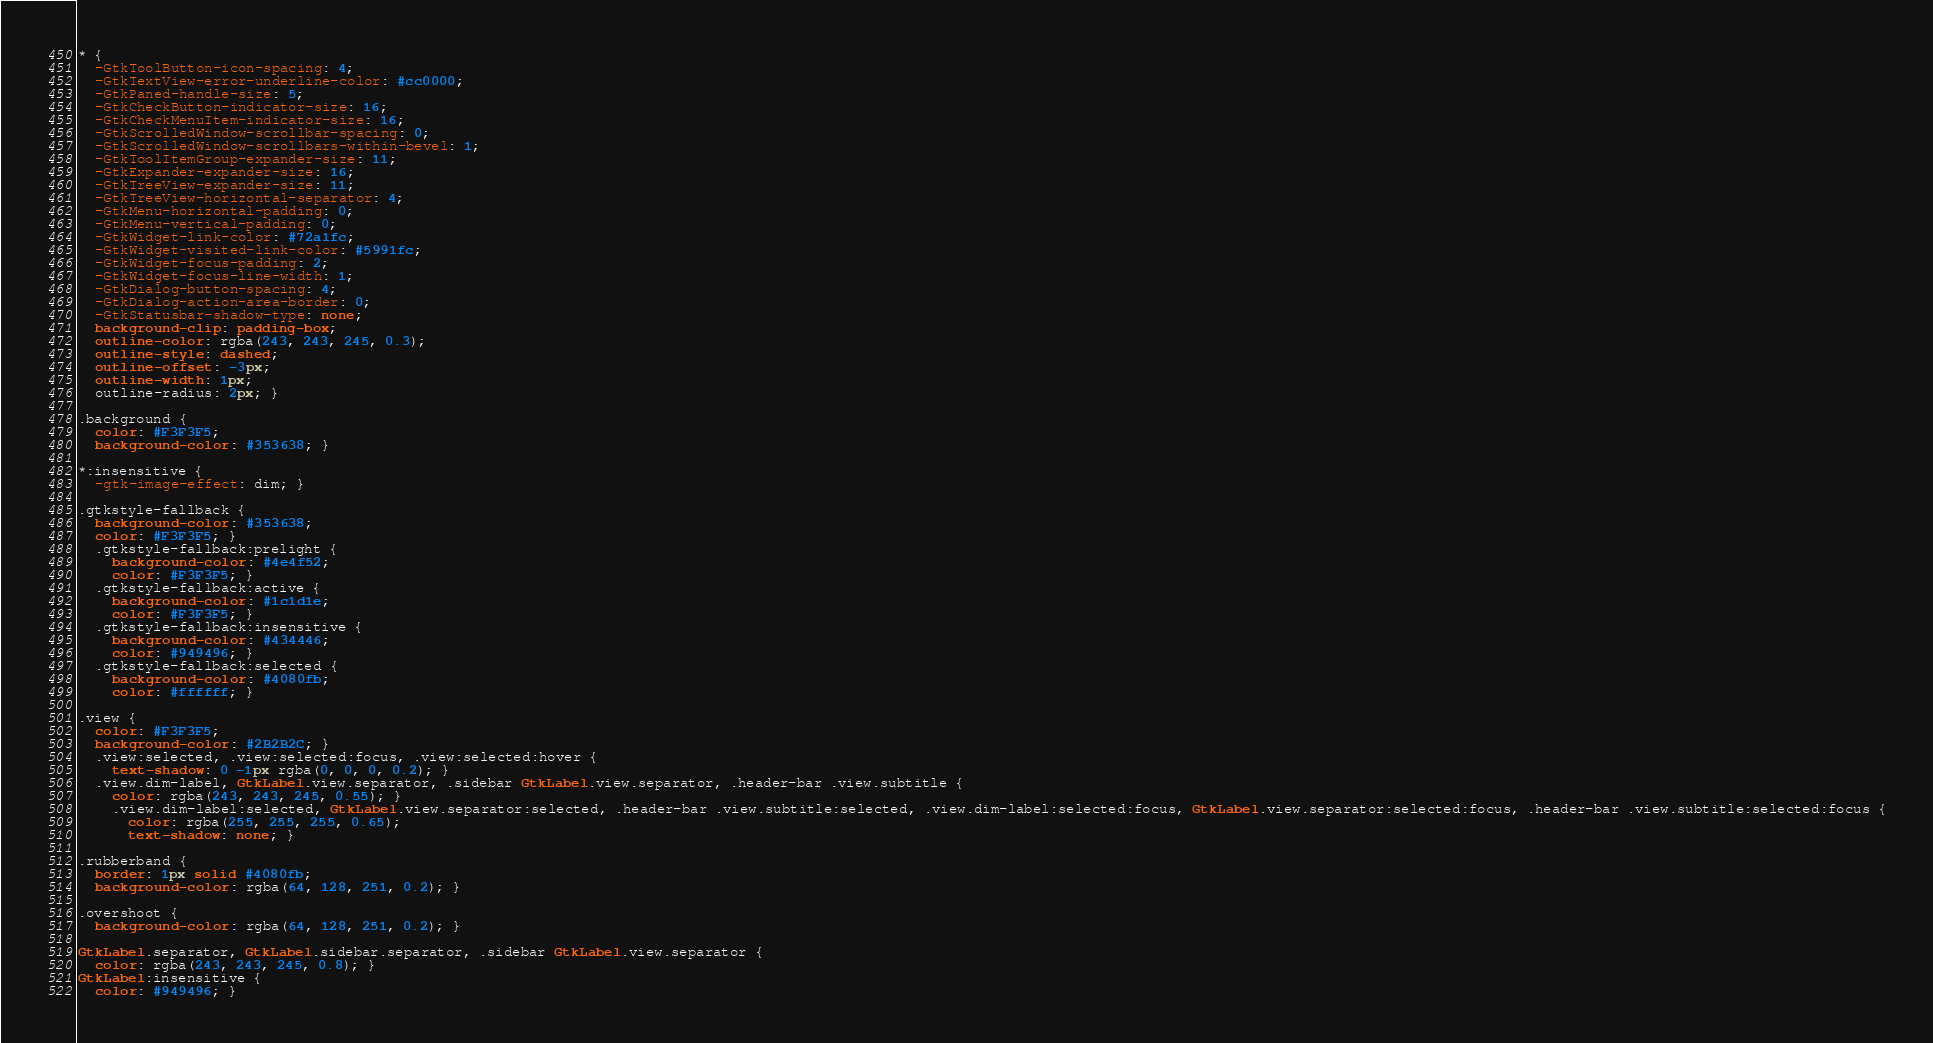<code> <loc_0><loc_0><loc_500><loc_500><_CSS_>* {
  -GtkToolButton-icon-spacing: 4;
  -GtkTextView-error-underline-color: #cc0000;
  -GtkPaned-handle-size: 5;
  -GtkCheckButton-indicator-size: 16;
  -GtkCheckMenuItem-indicator-size: 16;
  -GtkScrolledWindow-scrollbar-spacing: 0;
  -GtkScrolledWindow-scrollbars-within-bevel: 1;
  -GtkToolItemGroup-expander-size: 11;
  -GtkExpander-expander-size: 16;
  -GtkTreeView-expander-size: 11;
  -GtkTreeView-horizontal-separator: 4;
  -GtkMenu-horizontal-padding: 0;
  -GtkMenu-vertical-padding: 0;
  -GtkWidget-link-color: #72a1fc;
  -GtkWidget-visited-link-color: #5991fc;
  -GtkWidget-focus-padding: 2;
  -GtkWidget-focus-line-width: 1;
  -GtkDialog-button-spacing: 4;
  -GtkDialog-action-area-border: 0;
  -GtkStatusbar-shadow-type: none;
  background-clip: padding-box;
  outline-color: rgba(243, 243, 245, 0.3);
  outline-style: dashed;
  outline-offset: -3px;
  outline-width: 1px;
  outline-radius: 2px; }

.background {
  color: #F3F3F5;
  background-color: #353638; }

*:insensitive {
  -gtk-image-effect: dim; }

.gtkstyle-fallback {
  background-color: #353638;
  color: #F3F3F5; }
  .gtkstyle-fallback:prelight {
    background-color: #4e4f52;
    color: #F3F3F5; }
  .gtkstyle-fallback:active {
    background-color: #1c1d1e;
    color: #F3F3F5; }
  .gtkstyle-fallback:insensitive {
    background-color: #434446;
    color: #949496; }
  .gtkstyle-fallback:selected {
    background-color: #4080fb;
    color: #ffffff; }

.view {
  color: #F3F3F5;
  background-color: #2B2B2C; }
  .view:selected, .view:selected:focus, .view:selected:hover {
    text-shadow: 0 -1px rgba(0, 0, 0, 0.2); }
  .view.dim-label, GtkLabel.view.separator, .sidebar GtkLabel.view.separator, .header-bar .view.subtitle {
    color: rgba(243, 243, 245, 0.55); }
    .view.dim-label:selected, GtkLabel.view.separator:selected, .header-bar .view.subtitle:selected, .view.dim-label:selected:focus, GtkLabel.view.separator:selected:focus, .header-bar .view.subtitle:selected:focus {
      color: rgba(255, 255, 255, 0.65);
      text-shadow: none; }

.rubberband {
  border: 1px solid #4080fb;
  background-color: rgba(64, 128, 251, 0.2); }

.overshoot {
  background-color: rgba(64, 128, 251, 0.2); }

GtkLabel.separator, GtkLabel.sidebar.separator, .sidebar GtkLabel.view.separator {
  color: rgba(243, 243, 245, 0.8); }
GtkLabel:insensitive {
  color: #949496; }
</code> 